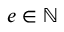<formula> <loc_0><loc_0><loc_500><loc_500>e \in \mathbb { N }</formula> 